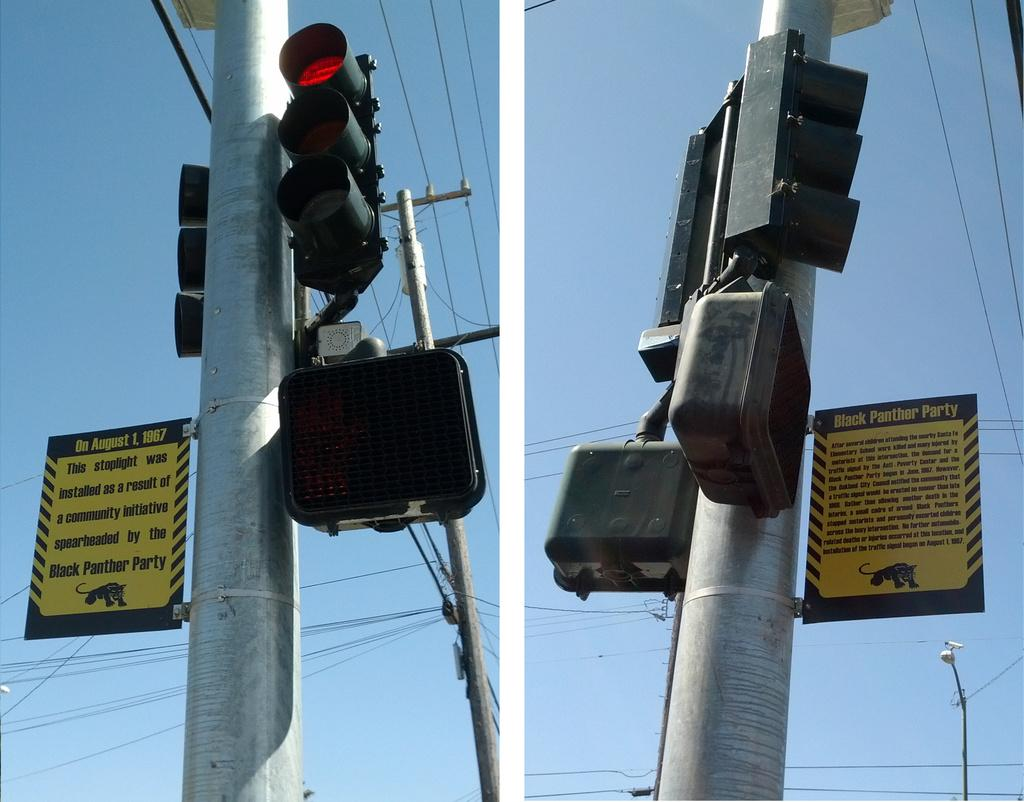<image>
Give a short and clear explanation of the subsequent image. A sign on a pole provides information about the Black Panther Party and a stop light installation. 